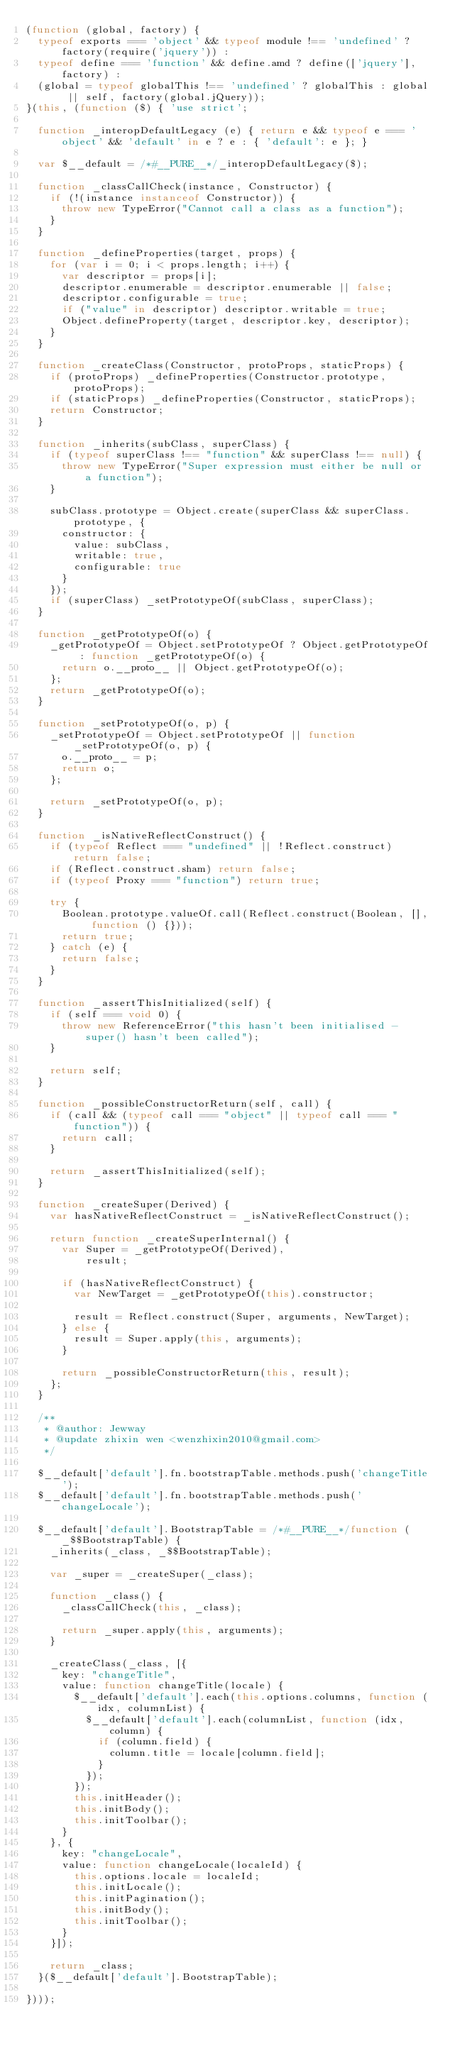Convert code to text. <code><loc_0><loc_0><loc_500><loc_500><_JavaScript_>(function (global, factory) {
  typeof exports === 'object' && typeof module !== 'undefined' ? factory(require('jquery')) :
  typeof define === 'function' && define.amd ? define(['jquery'], factory) :
  (global = typeof globalThis !== 'undefined' ? globalThis : global || self, factory(global.jQuery));
}(this, (function ($) { 'use strict';

  function _interopDefaultLegacy (e) { return e && typeof e === 'object' && 'default' in e ? e : { 'default': e }; }

  var $__default = /*#__PURE__*/_interopDefaultLegacy($);

  function _classCallCheck(instance, Constructor) {
    if (!(instance instanceof Constructor)) {
      throw new TypeError("Cannot call a class as a function");
    }
  }

  function _defineProperties(target, props) {
    for (var i = 0; i < props.length; i++) {
      var descriptor = props[i];
      descriptor.enumerable = descriptor.enumerable || false;
      descriptor.configurable = true;
      if ("value" in descriptor) descriptor.writable = true;
      Object.defineProperty(target, descriptor.key, descriptor);
    }
  }

  function _createClass(Constructor, protoProps, staticProps) {
    if (protoProps) _defineProperties(Constructor.prototype, protoProps);
    if (staticProps) _defineProperties(Constructor, staticProps);
    return Constructor;
  }

  function _inherits(subClass, superClass) {
    if (typeof superClass !== "function" && superClass !== null) {
      throw new TypeError("Super expression must either be null or a function");
    }

    subClass.prototype = Object.create(superClass && superClass.prototype, {
      constructor: {
        value: subClass,
        writable: true,
        configurable: true
      }
    });
    if (superClass) _setPrototypeOf(subClass, superClass);
  }

  function _getPrototypeOf(o) {
    _getPrototypeOf = Object.setPrototypeOf ? Object.getPrototypeOf : function _getPrototypeOf(o) {
      return o.__proto__ || Object.getPrototypeOf(o);
    };
    return _getPrototypeOf(o);
  }

  function _setPrototypeOf(o, p) {
    _setPrototypeOf = Object.setPrototypeOf || function _setPrototypeOf(o, p) {
      o.__proto__ = p;
      return o;
    };

    return _setPrototypeOf(o, p);
  }

  function _isNativeReflectConstruct() {
    if (typeof Reflect === "undefined" || !Reflect.construct) return false;
    if (Reflect.construct.sham) return false;
    if (typeof Proxy === "function") return true;

    try {
      Boolean.prototype.valueOf.call(Reflect.construct(Boolean, [], function () {}));
      return true;
    } catch (e) {
      return false;
    }
  }

  function _assertThisInitialized(self) {
    if (self === void 0) {
      throw new ReferenceError("this hasn't been initialised - super() hasn't been called");
    }

    return self;
  }

  function _possibleConstructorReturn(self, call) {
    if (call && (typeof call === "object" || typeof call === "function")) {
      return call;
    }

    return _assertThisInitialized(self);
  }

  function _createSuper(Derived) {
    var hasNativeReflectConstruct = _isNativeReflectConstruct();

    return function _createSuperInternal() {
      var Super = _getPrototypeOf(Derived),
          result;

      if (hasNativeReflectConstruct) {
        var NewTarget = _getPrototypeOf(this).constructor;

        result = Reflect.construct(Super, arguments, NewTarget);
      } else {
        result = Super.apply(this, arguments);
      }

      return _possibleConstructorReturn(this, result);
    };
  }

  /**
   * @author: Jewway
   * @update zhixin wen <wenzhixin2010@gmail.com>
   */

  $__default['default'].fn.bootstrapTable.methods.push('changeTitle');
  $__default['default'].fn.bootstrapTable.methods.push('changeLocale');

  $__default['default'].BootstrapTable = /*#__PURE__*/function (_$$BootstrapTable) {
    _inherits(_class, _$$BootstrapTable);

    var _super = _createSuper(_class);

    function _class() {
      _classCallCheck(this, _class);

      return _super.apply(this, arguments);
    }

    _createClass(_class, [{
      key: "changeTitle",
      value: function changeTitle(locale) {
        $__default['default'].each(this.options.columns, function (idx, columnList) {
          $__default['default'].each(columnList, function (idx, column) {
            if (column.field) {
              column.title = locale[column.field];
            }
          });
        });
        this.initHeader();
        this.initBody();
        this.initToolbar();
      }
    }, {
      key: "changeLocale",
      value: function changeLocale(localeId) {
        this.options.locale = localeId;
        this.initLocale();
        this.initPagination();
        this.initBody();
        this.initToolbar();
      }
    }]);

    return _class;
  }($__default['default'].BootstrapTable);

})));
</code> 